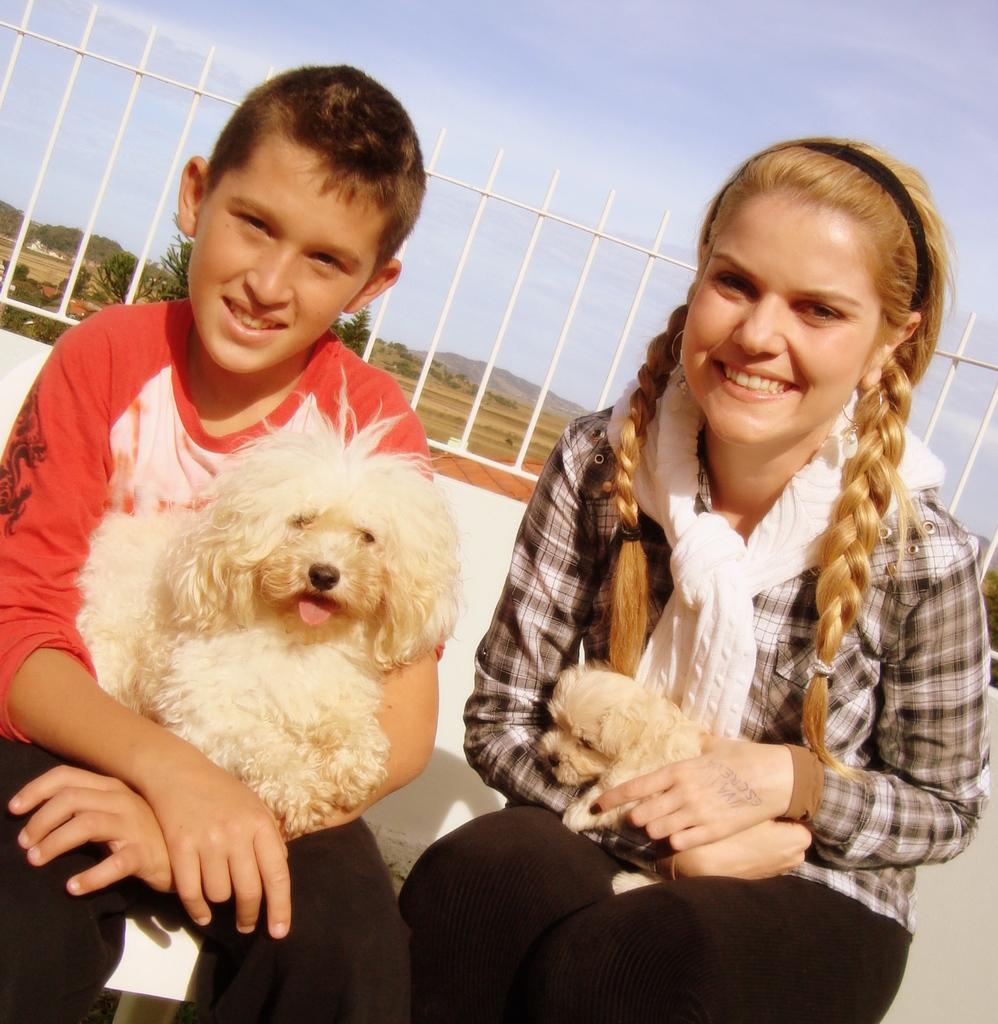How many people are in the image? There are two people in the image, a man and a woman. What are the man and woman doing in the image? They are holding a dog with their hands. What is the emotional expression of the man and woman in the image? The man and woman are smiling. What can be seen in the background of the image? There is a sky and trees visible in the background of the image. What color are the bricks on the dog's eye in the image? There are no bricks or eyes on the dog in the image; it is a live dog being held by the man and woman. 